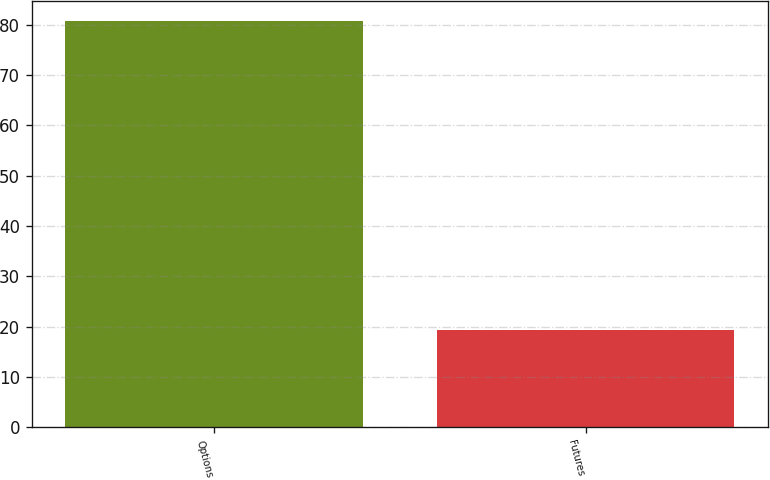<chart> <loc_0><loc_0><loc_500><loc_500><bar_chart><fcel>Options<fcel>Futures<nl><fcel>80.7<fcel>19.3<nl></chart> 